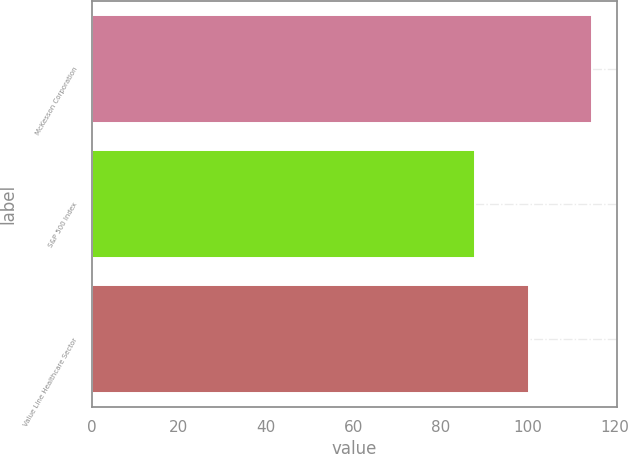Convert chart to OTSL. <chart><loc_0><loc_0><loc_500><loc_500><bar_chart><fcel>McKesson Corporation<fcel>S&P 500 Index<fcel>Value Line Healthcare Sector<nl><fcel>114.92<fcel>88.02<fcel>100.35<nl></chart> 